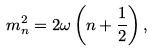<formula> <loc_0><loc_0><loc_500><loc_500>m _ { n } ^ { 2 } = 2 \omega \left ( n + \frac { 1 } { 2 } \right ) ,</formula> 